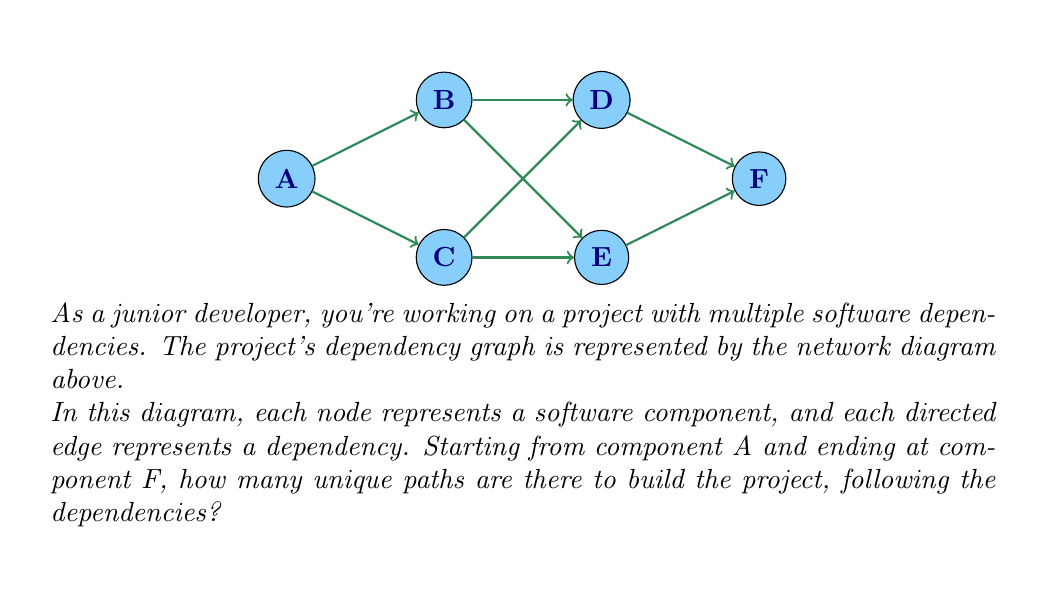Can you answer this question? To solve this problem, we can use a systematic approach:

1) First, let's identify all possible paths from A to F:
   - A → B → D → F
   - A → B → E → F
   - A → C → D → F
   - A → C → E → F

2) Now, we need to count these paths. We can do this by using the following method:
   
   Let $P(X)$ be the number of paths from node X to F.
   
   We can see that:
   $$P(F) = 1$$ (there's only one way to get from F to F)
   $$P(D) = P(F) = 1$$
   $$P(E) = P(F) = 1$$
   $$P(B) = P(D) + P(E) = 1 + 1 = 2$$
   $$P(C) = P(D) + P(E) = 1 + 1 = 2$$
   $$P(A) = P(B) + P(C) = 2 + 2 = 4$$

3) Therefore, the total number of unique paths from A to F is $P(A) = 4$.

This method is based on the principle of dynamic programming, where we solve the problem for smaller subproblems (nodes closer to F) and use these results to solve for nodes further away.
Answer: 4 unique paths 